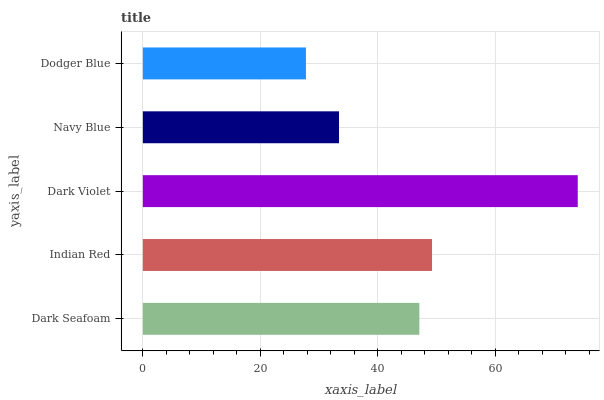Is Dodger Blue the minimum?
Answer yes or no. Yes. Is Dark Violet the maximum?
Answer yes or no. Yes. Is Indian Red the minimum?
Answer yes or no. No. Is Indian Red the maximum?
Answer yes or no. No. Is Indian Red greater than Dark Seafoam?
Answer yes or no. Yes. Is Dark Seafoam less than Indian Red?
Answer yes or no. Yes. Is Dark Seafoam greater than Indian Red?
Answer yes or no. No. Is Indian Red less than Dark Seafoam?
Answer yes or no. No. Is Dark Seafoam the high median?
Answer yes or no. Yes. Is Dark Seafoam the low median?
Answer yes or no. Yes. Is Indian Red the high median?
Answer yes or no. No. Is Dodger Blue the low median?
Answer yes or no. No. 